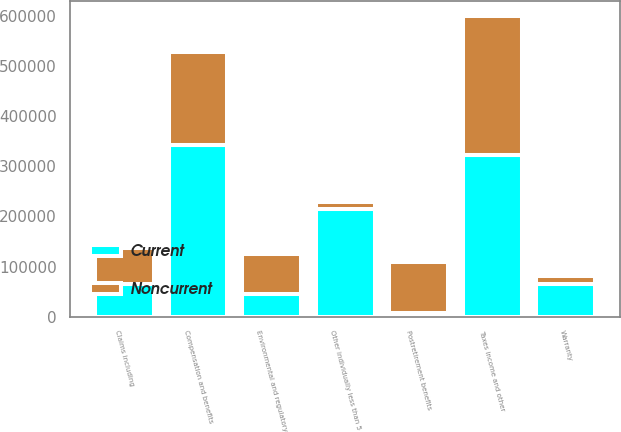Convert chart. <chart><loc_0><loc_0><loc_500><loc_500><stacked_bar_chart><ecel><fcel>Compensation and benefits<fcel>Claims including<fcel>Postretirement benefits<fcel>Environmental and regulatory<fcel>Taxes income and other<fcel>Warranty<fcel>Other individually less than 5<nl><fcel>Current<fcel>342969<fcel>64281<fcel>8000<fcel>44915<fcel>323257<fcel>65105<fcel>215939<nl><fcel>Noncurrent<fcel>186523<fcel>71821<fcel>100900<fcel>80963<fcel>277652<fcel>15001<fcel>13530<nl></chart> 